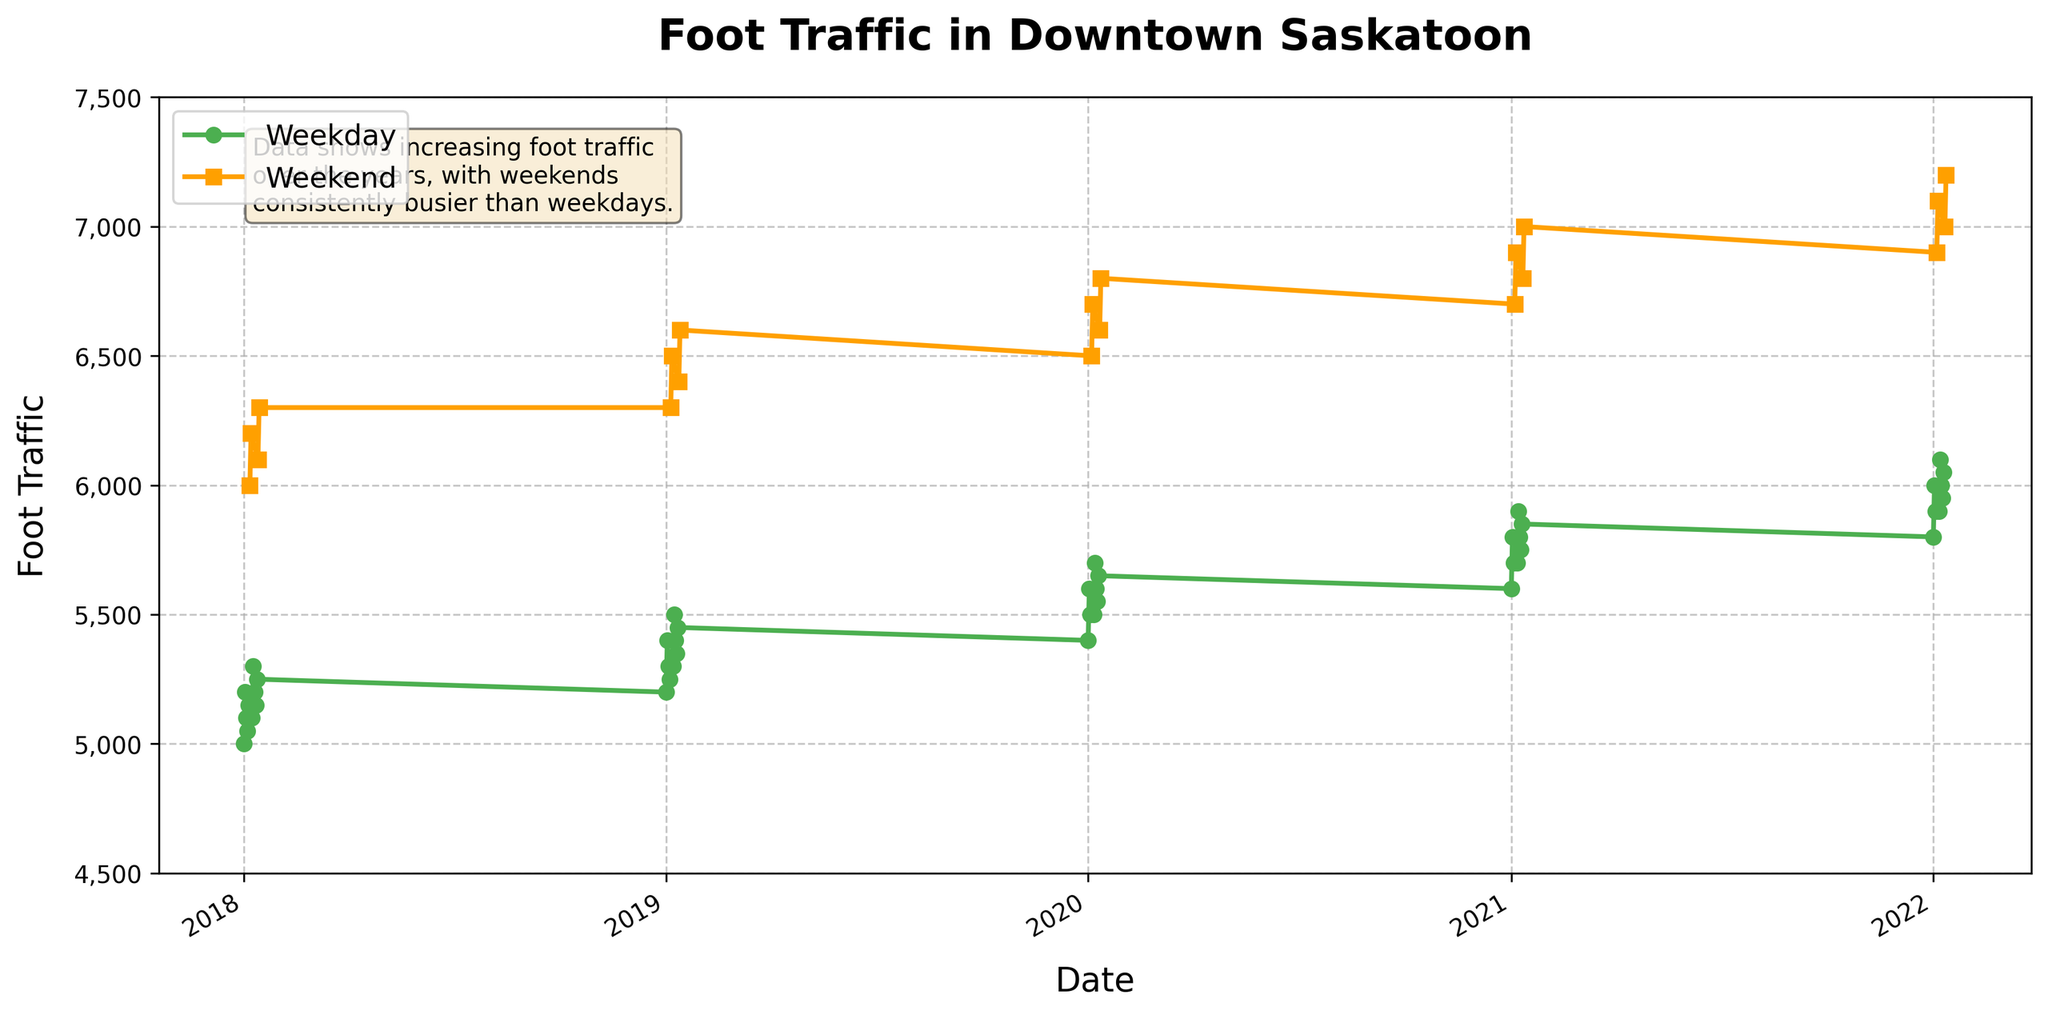What is the title of the figure? The title is located at the top of the figure and provides an overall description of the data being visualized. In this case, it tells us what the graph is about.
Answer: Foot Traffic in Downtown Saskatoon What colors are used to represent weekdays and weekends? The figure uses different colors to differentiate weekdays and weekends. The color of the lines or markers can be observed directly in the figure.
Answer: Green for weekdays and orange for weekends Which day type generally has higher foot traffic? By comparing the general height of the lines or markers representing weekdays and weekends, we can determine which has higher foot traffic. The weekends tend to have higher values.
Answer: Weekends What is the approximate range of foot traffic for weekdays in 2020? From looking at the figure, we can observe the variation in foot traffic over the year 2020 by focusing on the section labeled 'Weekday' and noting the highest and lowest points.
Answer: 5400 to 5700 Does foot traffic show an increasing trend over the years for weekdays? By observing the positions of the markers over time from 2018 to 2022, we can see if there is a general upward or downward trend in the weekday foot traffic data points.
Answer: Yes By how much did the highest foot traffic increase from 2018 to 2022 for weekends? Find the peak points for weekends in 2018 and 2022 from the plot and then subtract the 2018 value from the 2022 value to get the increase.
Answer: 1200 What is the average foot traffic on weekends in 2021? To find the average, identify the weekend foot traffic values for 2021, sum them, and then divide by the number of weekend data points for that year.
Answer: (6700 + 6900 + 6800 + 7000) / 4 = 6850 Which year experienced the least increase in weekday foot traffic compared to the previous year? Compare foot traffic values at the start and end of each year, then check the differences from one year to the next.
Answer: 2019 to 2020 Is there a noticeable periodic pattern in foot traffic between weekends and weekdays? Look for repeating cycles or patterns in the plot between weekends and weekdays throughout the data duration. The alternating peaks and troughs indicate a periodic pattern.
Answer: Yes On average, how much higher is weekend foot traffic compared to weekdays in 2019? Calculate the average foot traffic for weekdays and weekends in 2019 separately, then subtract the weekday average from the weekend average.
Answer: (6300 + 6500 + 6400 + 6600)/4 - (5200 + 5400 + 5300 + 5250 + 5300 + 5500 + 5400 + 5350 + 5450) / 9 = 6450 - 5361 ≈ 1089 